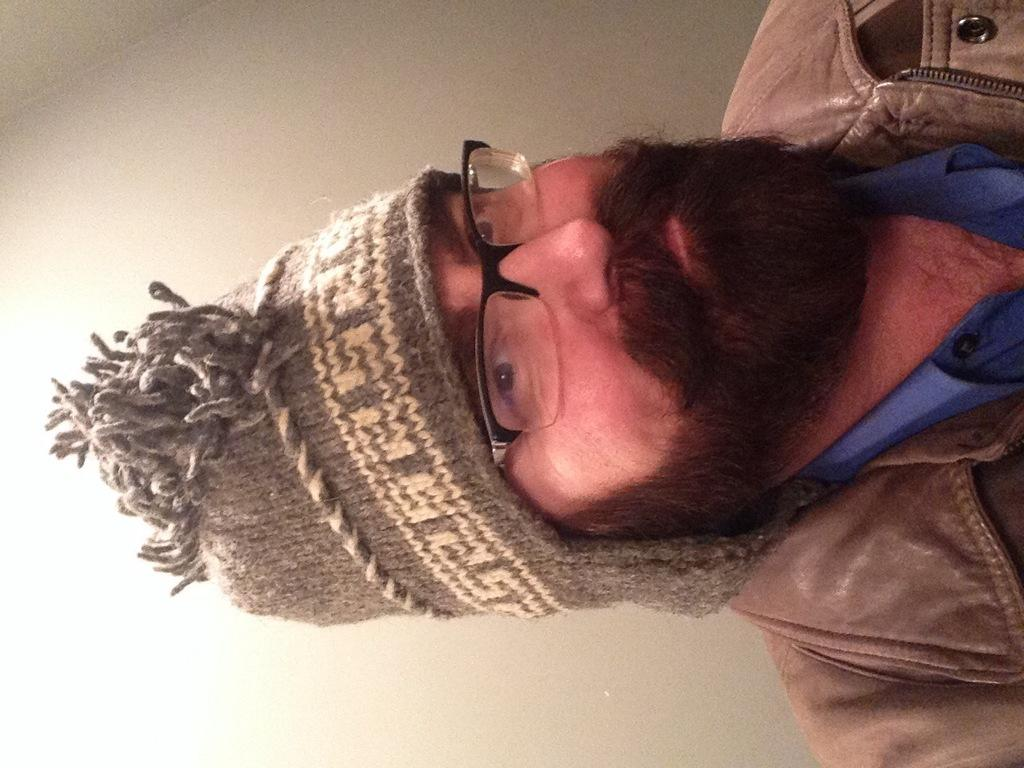Who is present in the image? There is a man in the image. What is the man wearing on his head? The man is wearing a cap. What type of eyewear is the man wearing? The man is wearing glasses. What can be seen behind the man in the image? There is a plain wall in the background of the image. What type of fiction is the man reading in the image? There is no book or any indication of reading in the image, so it cannot be determined if the man is reading fiction. 